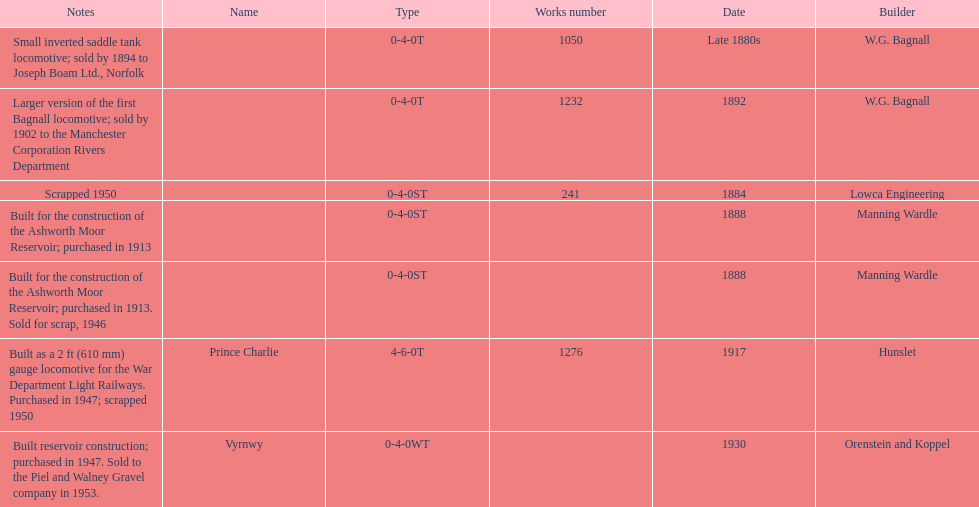How many trains were discarded? 3. 